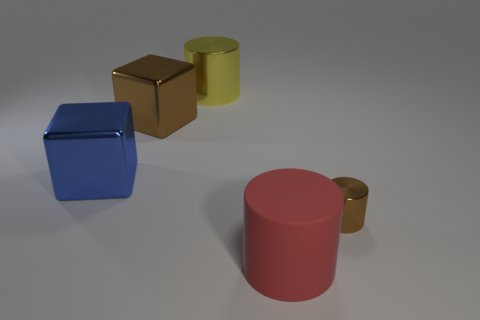Add 2 small brown cylinders. How many objects exist? 7 Subtract all blocks. How many objects are left? 3 Subtract 1 brown cylinders. How many objects are left? 4 Subtract all purple blocks. Subtract all brown objects. How many objects are left? 3 Add 3 yellow objects. How many yellow objects are left? 4 Add 3 large yellow metal cylinders. How many large yellow metal cylinders exist? 4 